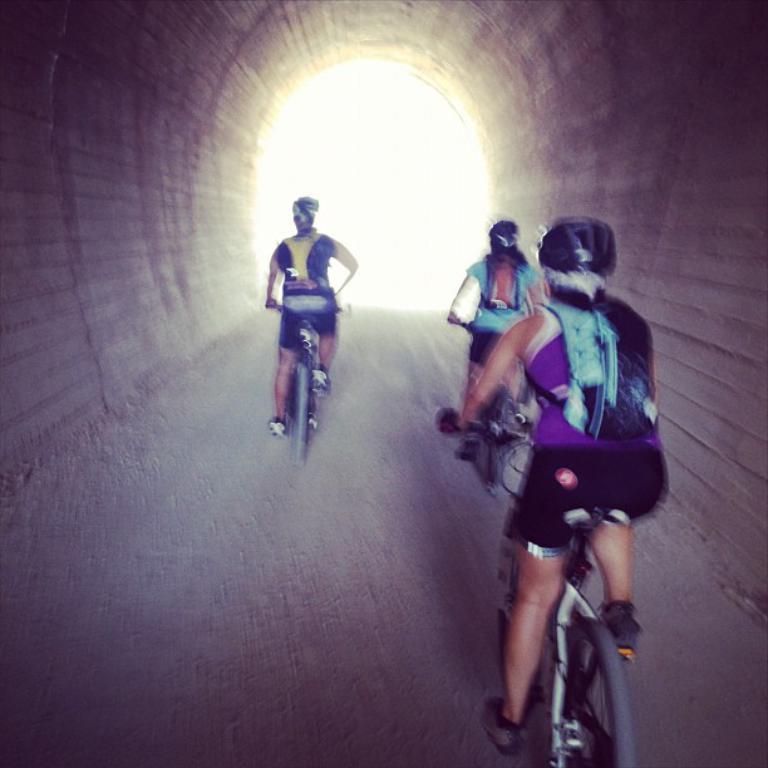How would you summarize this image in a sentence or two? In the middle of the image few people are riding bicycles on the road and there is a tunnel. 